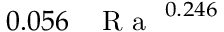<formula> <loc_0><loc_0><loc_500><loc_500>0 . 0 5 6 \, { R a } ^ { 0 . 2 4 6 }</formula> 